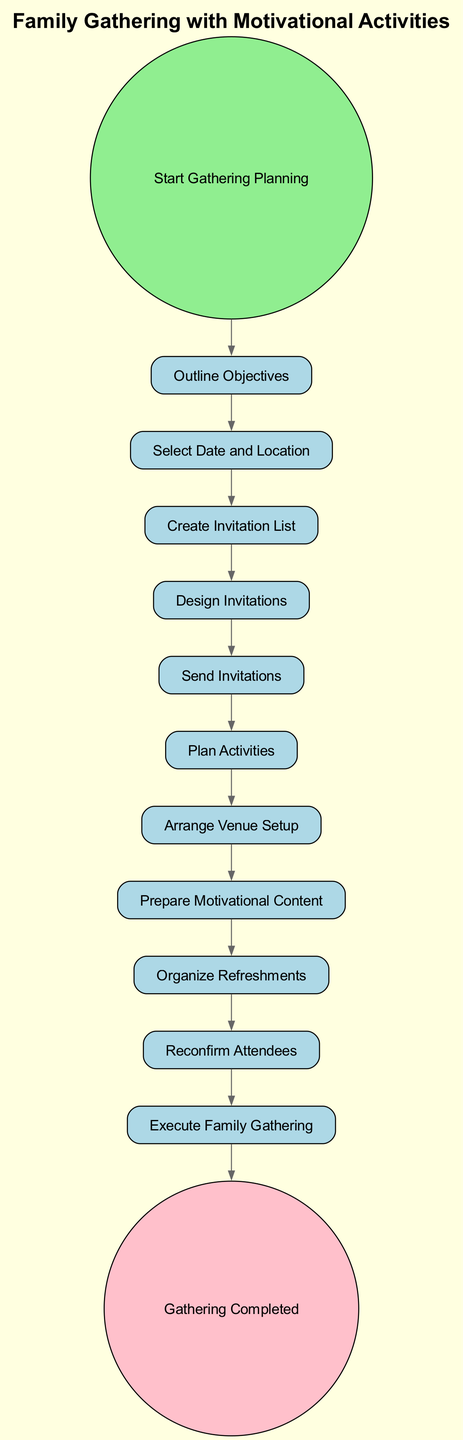What is the first task in the diagram? The first task in the diagram is indicated by the arrow leading from the "Start Gathering Planning" node to the task node labeled "Outline Objectives."
Answer: Outline Objectives How many tasks are present in the diagram? The diagram includes 11 tasks, which can be counted by reviewing all the task nodes listed between the start and end events.
Answer: 11 Which task comes immediately after "Send Invitations"? To determine the task that comes immediately after "Send Invitations," we follow the edge that leads from the "Send Invitations" node to the next task in the sequence, which is "Plan Activities."
Answer: Plan Activities What is the final step before the gathering is completed? The final step before reaching the "Gathering Completed" node is "Execute Family Gathering," as indicated by the flow of the diagram leading to the end event.
Answer: Execute Family Gathering What task is positioned between "Arrange Venue Setup" and "Prepare Motivational Content"? By reviewing the edges connecting the nodes in the diagram, we find that "Prepare Motivational Content" is directly after "Arrange Venue Setup," making it the next task in the sequence.
Answer: Prepare Motivational Content How many edges are present in the diagram? The number of edges can be counted in the diagram; each task has an arrow indicating the flow from one to another, and there are 11 edges connecting the tasks.
Answer: 11 